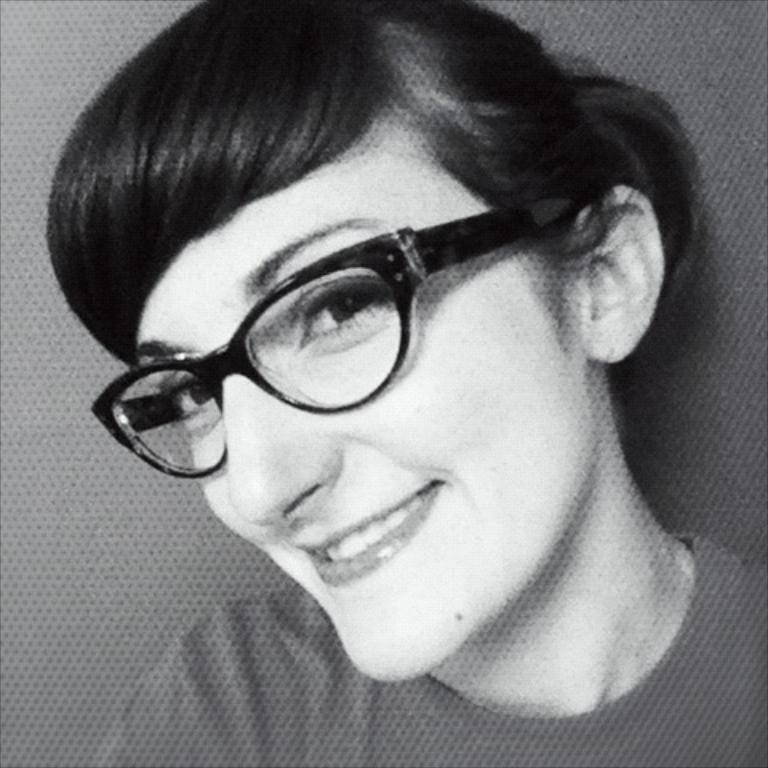What is the color scheme of the image? The picture is in black and white. Who is present in the image? There is a woman in the image. What is the woman wearing in the image? The woman is wearing spectacles. How many bushes can be seen in the image? There are no bushes present in the image, as it is a black and white picture featuring a woman wearing spectacles. What type of wing is visible in the image? There is no wing present in the image; it only features a woman wearing spectacles. 